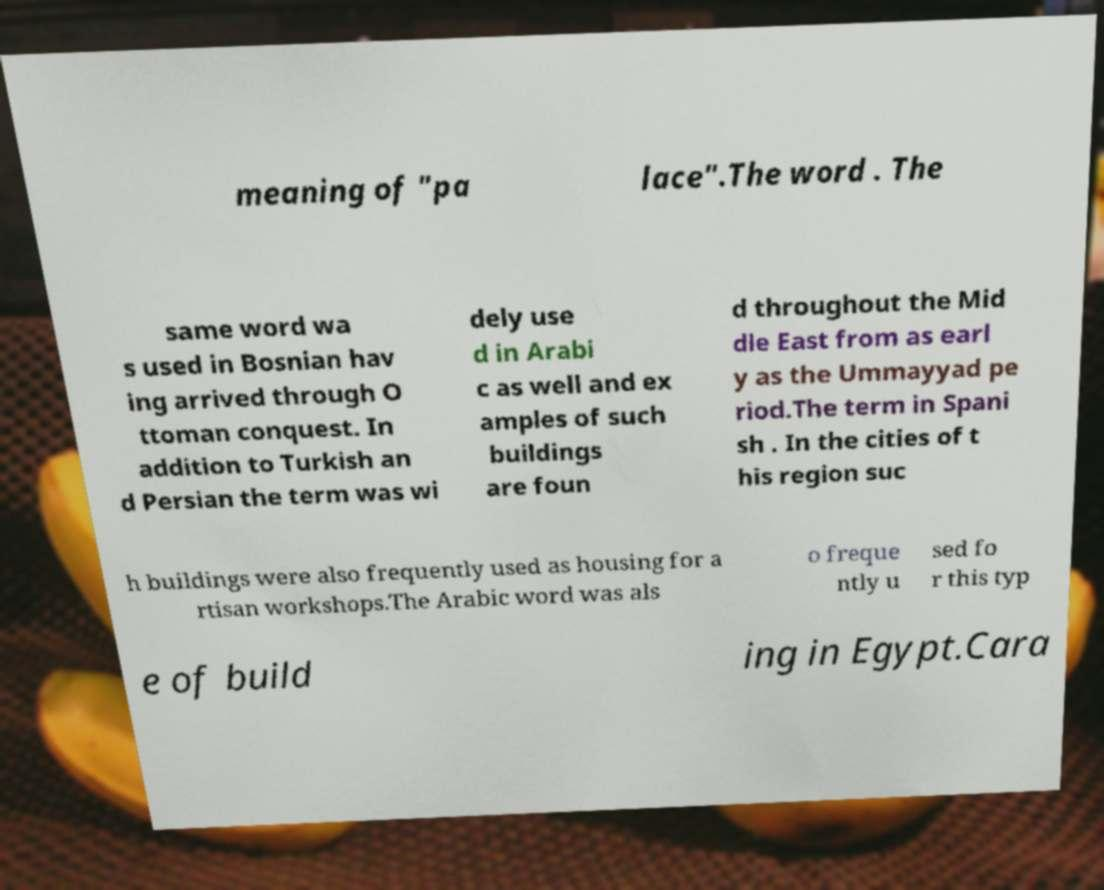For documentation purposes, I need the text within this image transcribed. Could you provide that? meaning of "pa lace".The word . The same word wa s used in Bosnian hav ing arrived through O ttoman conquest. In addition to Turkish an d Persian the term was wi dely use d in Arabi c as well and ex amples of such buildings are foun d throughout the Mid dle East from as earl y as the Ummayyad pe riod.The term in Spani sh . In the cities of t his region suc h buildings were also frequently used as housing for a rtisan workshops.The Arabic word was als o freque ntly u sed fo r this typ e of build ing in Egypt.Cara 